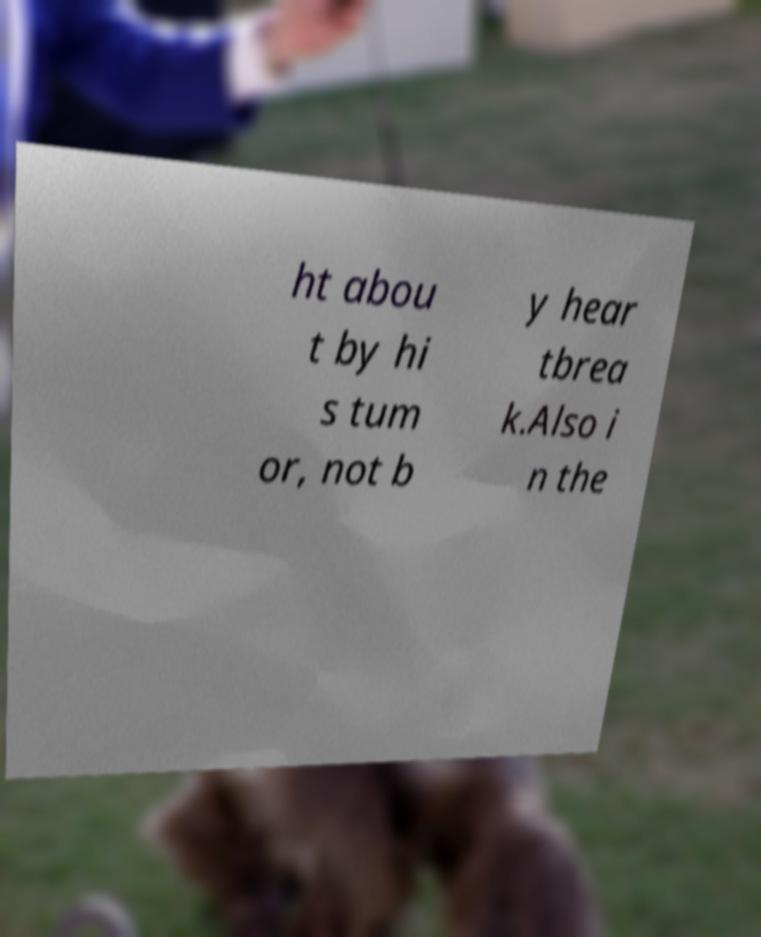Please read and relay the text visible in this image. What does it say? ht abou t by hi s tum or, not b y hear tbrea k.Also i n the 